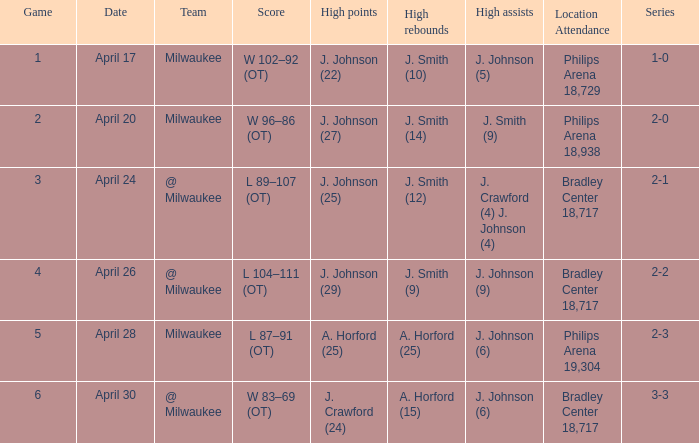What was the result of the sixth game? W 83–69 (OT). 